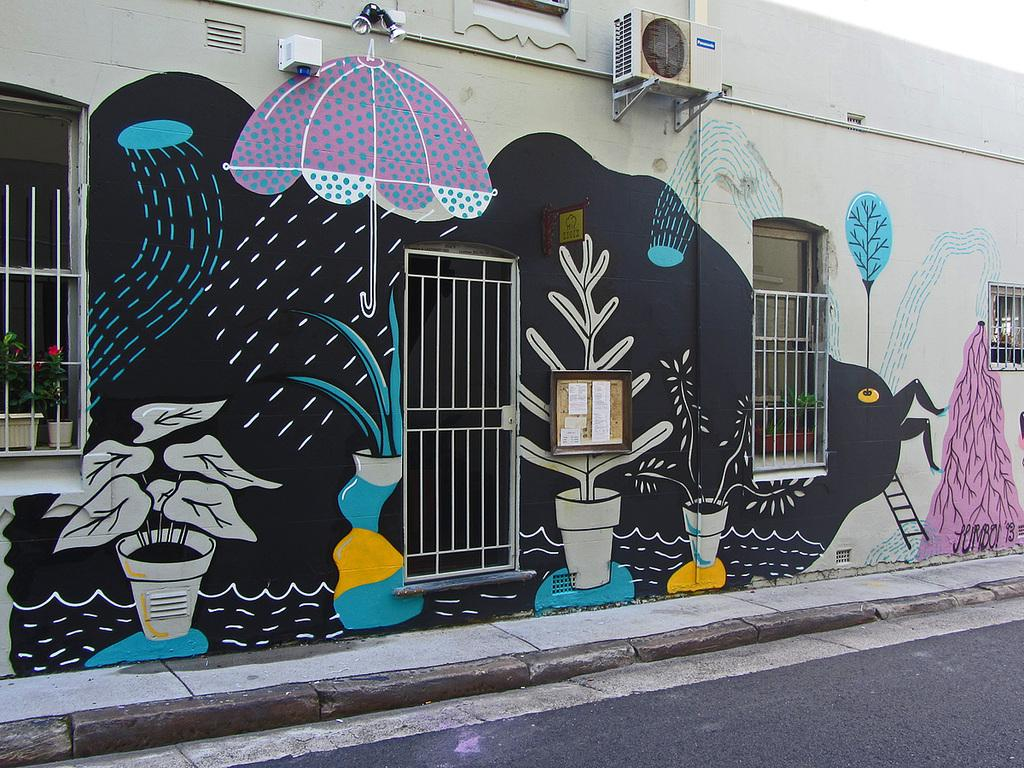What is present on the wall in the image? There is a painting on the wall in the image. What architectural feature can be seen in the image? There is a fence in the image. What can be used to enter or exit a building in the image? There is a door in the image. What type of vegetation is present in the image? There is a plant pot in the image. What is a feature of the road in the image? There is a road in the image. What type of lighting is present in the image? There are skylights in the image. What is a flat, thin, and usually rectangular object in the image? There is a board in the image. Can you describe the harmony between the ghost and the painting in the image? There is no ghost present in the image, so it is not possible to describe any harmony between a ghost and the painting. 